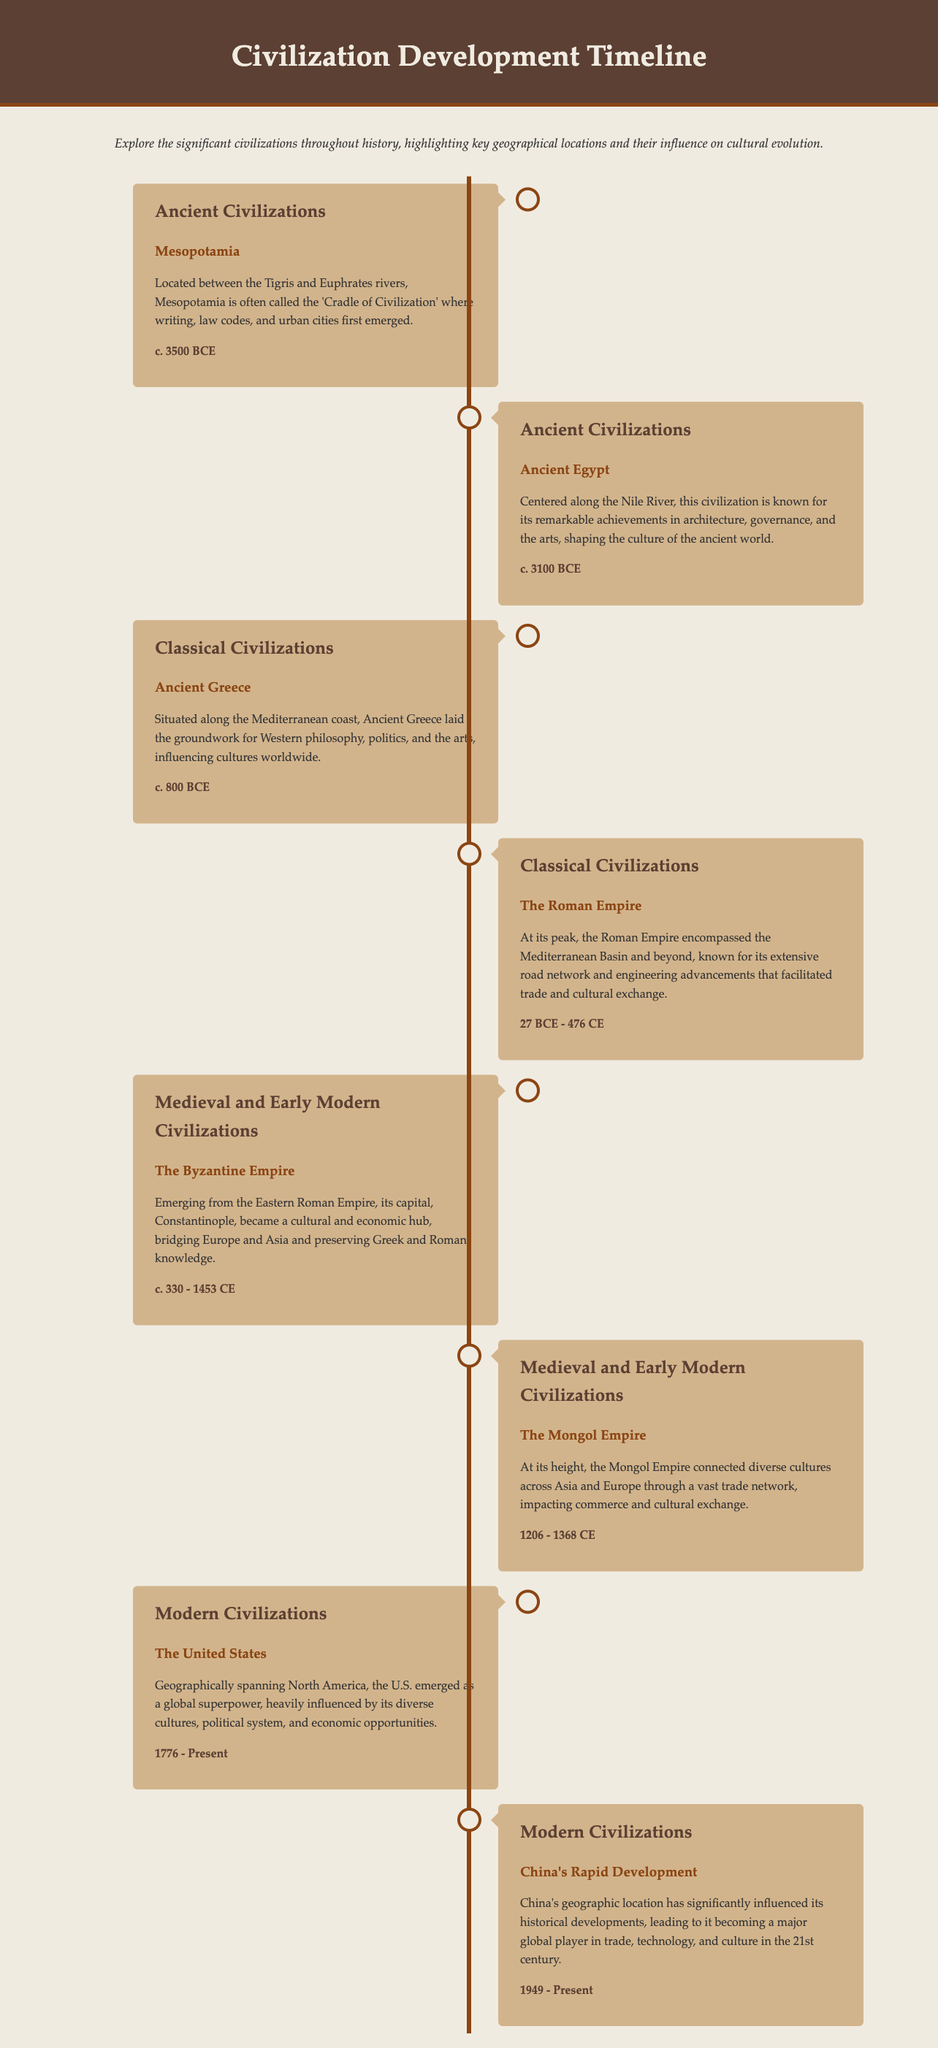What civilization is known as the 'Cradle of Civilization'? The document describes Mesopotamia as the 'Cradle of Civilization' due to its early developments in writing and urban cities.
Answer: Mesopotamia What geographical feature is Ancient Egypt centered around? The document states that Ancient Egypt is centered along the Nile River, highlighting its geographical significance.
Answer: Nile River What time period does the Roman Empire span? The document lists the time period of the Roman Empire as being from 27 BCE to 476 CE.
Answer: 27 BCE - 476 CE Which civilization is stated to have emerged in 1776? The document notes the emergence of The United States in the year 1776, marking its historical significance.
Answer: The United States What was the capital of the Byzantine Empire? The document mentions that Constantinople was the capital of the Byzantine Empire, showcasing its importance as a cultural hub.
Answer: Constantinople How long did the Mongol Empire last? According to the document, the Mongol Empire lasted from 1206 to 1368 CE.
Answer: 1206 - 1368 CE Which two civilizations mentioned became global superpowers? The document highlights The United States and China’s Rapid Development as civilizations that emerged as global superpowers.
Answer: The United States and China What was the key characteristic of Ancient Greece mentioned in the document? The document states that Ancient Greece laid the groundwork for Western philosophy, politics, and the arts, highlighting its cultural impact.
Answer: Groundwork for Western philosophy What is the main influence noted about China's geographical location? The document indicates that China's geographic location has significantly influenced its historical developments and global role.
Answer: Historical developments 